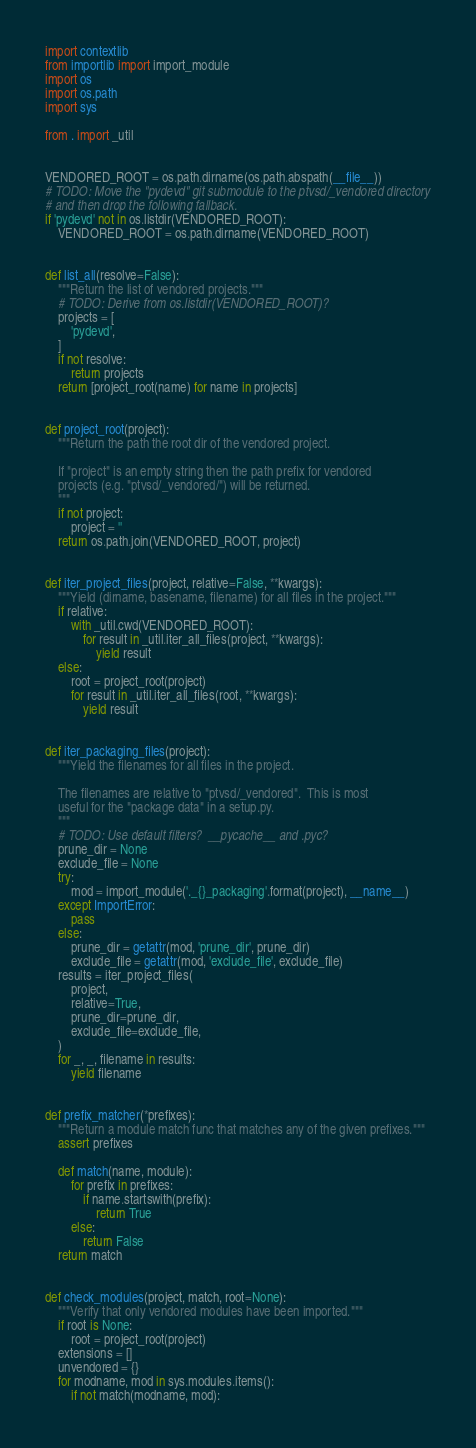Convert code to text. <code><loc_0><loc_0><loc_500><loc_500><_Python_>import contextlib
from importlib import import_module
import os
import os.path
import sys

from . import _util


VENDORED_ROOT = os.path.dirname(os.path.abspath(__file__))
# TODO: Move the "pydevd" git submodule to the ptvsd/_vendored directory
# and then drop the following fallback.
if 'pydevd' not in os.listdir(VENDORED_ROOT):
    VENDORED_ROOT = os.path.dirname(VENDORED_ROOT)


def list_all(resolve=False):
    """Return the list of vendored projects."""
    # TODO: Derive from os.listdir(VENDORED_ROOT)?
    projects = [
        'pydevd',
    ]
    if not resolve:
        return projects
    return [project_root(name) for name in projects]


def project_root(project):
    """Return the path the root dir of the vendored project.

    If "project" is an empty string then the path prefix for vendored
    projects (e.g. "ptvsd/_vendored/") will be returned.
    """
    if not project:
        project = ''
    return os.path.join(VENDORED_ROOT, project)


def iter_project_files(project, relative=False, **kwargs):
    """Yield (dirname, basename, filename) for all files in the project."""
    if relative:
        with _util.cwd(VENDORED_ROOT):
            for result in _util.iter_all_files(project, **kwargs):
                yield result
    else:
        root = project_root(project)
        for result in _util.iter_all_files(root, **kwargs):
            yield result


def iter_packaging_files(project):
    """Yield the filenames for all files in the project.

    The filenames are relative to "ptvsd/_vendored".  This is most
    useful for the "package data" in a setup.py.
    """
    # TODO: Use default filters?  __pycache__ and .pyc?
    prune_dir = None
    exclude_file = None
    try:
        mod = import_module('._{}_packaging'.format(project), __name__)
    except ImportError:
        pass
    else:
        prune_dir = getattr(mod, 'prune_dir', prune_dir)
        exclude_file = getattr(mod, 'exclude_file', exclude_file)
    results = iter_project_files(
        project,
        relative=True,
        prune_dir=prune_dir,
        exclude_file=exclude_file,
    )
    for _, _, filename in results:
        yield filename


def prefix_matcher(*prefixes):
    """Return a module match func that matches any of the given prefixes."""
    assert prefixes

    def match(name, module):
        for prefix in prefixes:
            if name.startswith(prefix):
                return True
        else:
            return False
    return match


def check_modules(project, match, root=None):
    """Verify that only vendored modules have been imported."""
    if root is None:
        root = project_root(project)
    extensions = []
    unvendored = {}
    for modname, mod in sys.modules.items():
        if not match(modname, mod):</code> 